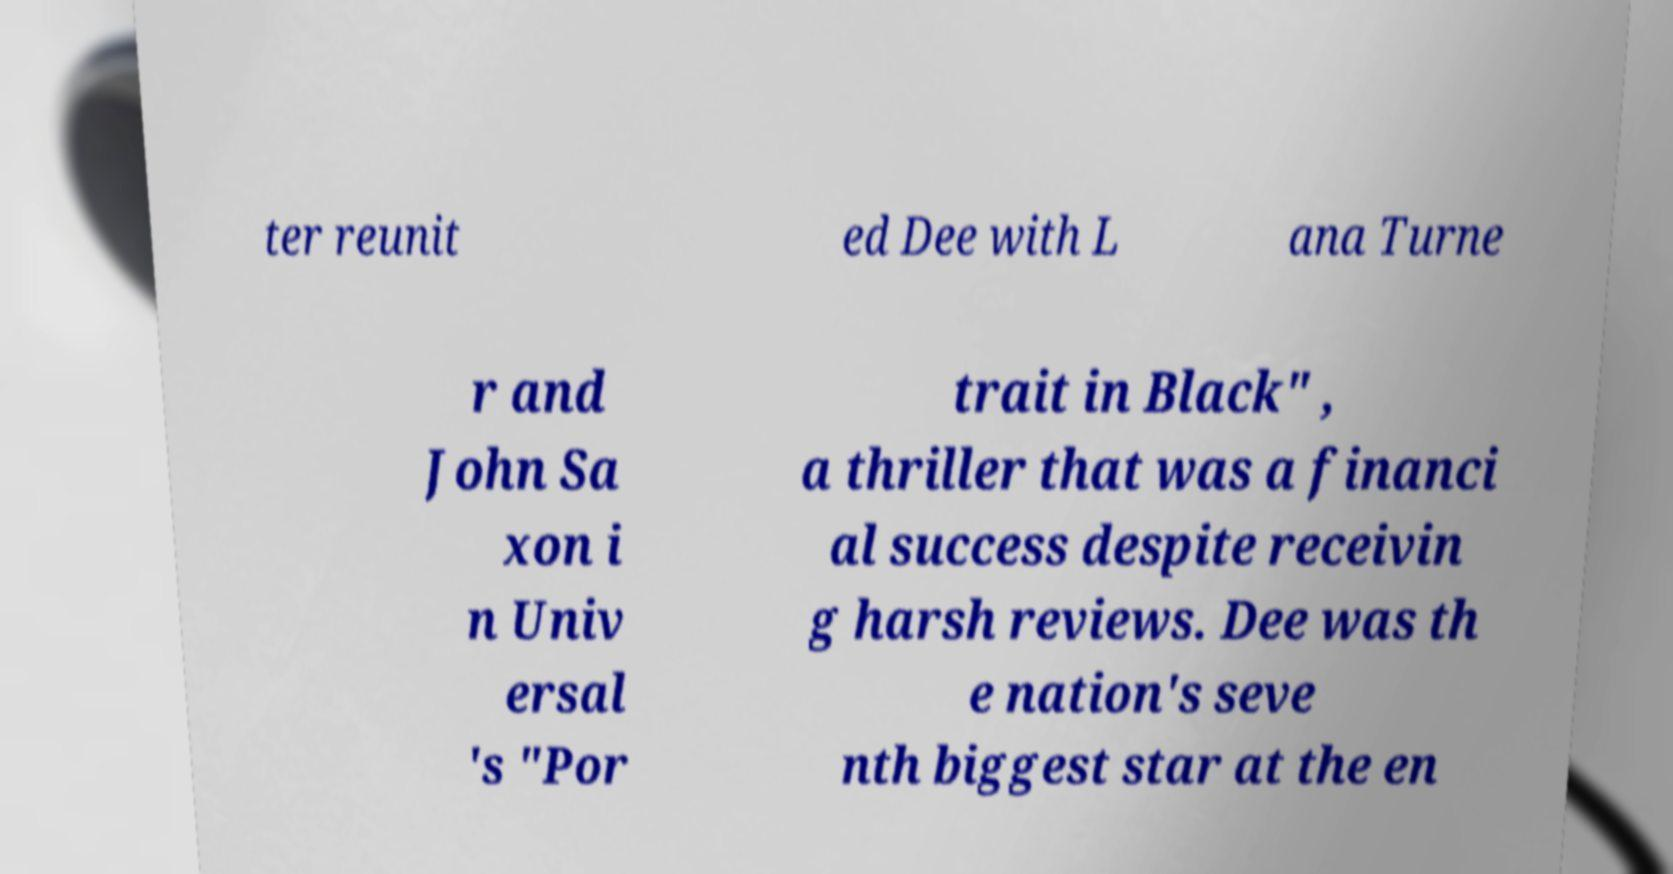Could you extract and type out the text from this image? ter reunit ed Dee with L ana Turne r and John Sa xon i n Univ ersal 's "Por trait in Black" , a thriller that was a financi al success despite receivin g harsh reviews. Dee was th e nation's seve nth biggest star at the en 